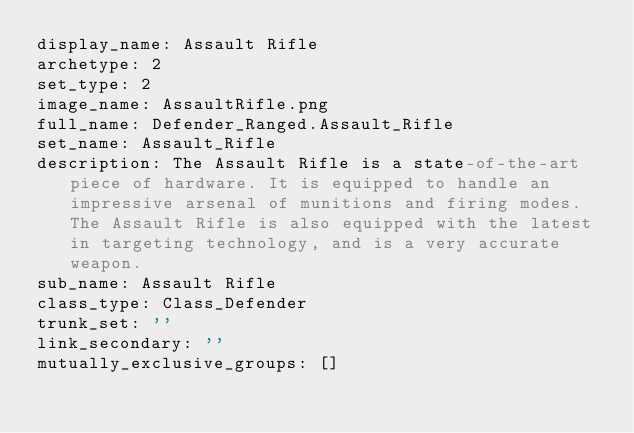Convert code to text. <code><loc_0><loc_0><loc_500><loc_500><_YAML_>display_name: Assault Rifle
archetype: 2
set_type: 2
image_name: AssaultRifle.png
full_name: Defender_Ranged.Assault_Rifle
set_name: Assault_Rifle
description: The Assault Rifle is a state-of-the-art piece of hardware. It is equipped to handle an impressive arsenal of munitions and firing modes. The Assault Rifle is also equipped with the latest in targeting technology, and is a very accurate weapon.
sub_name: Assault Rifle
class_type: Class_Defender
trunk_set: ''
link_secondary: ''
mutually_exclusive_groups: []
</code> 